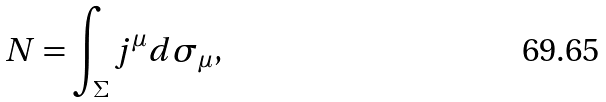<formula> <loc_0><loc_0><loc_500><loc_500>N = \int _ { \Sigma } j ^ { \mu } d \sigma _ { \mu } ,</formula> 